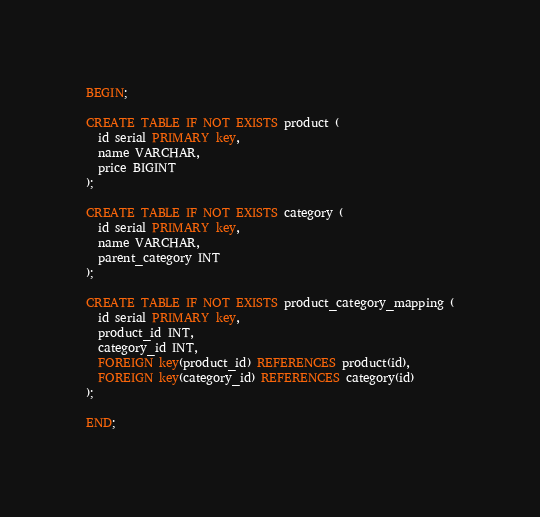<code> <loc_0><loc_0><loc_500><loc_500><_SQL_>BEGIN;

CREATE TABLE IF NOT EXISTS product (
  id serial PRIMARY key, 
  name VARCHAR, 
  price BIGINT
);

CREATE TABLE IF NOT EXISTS category (
  id serial PRIMARY key, 
  name VARCHAR,
  parent_category INT
);

CREATE TABLE IF NOT EXISTS product_category_mapping (
  id serial PRIMARY key, 
  product_id INT, 
  category_id INT, 
  FOREIGN key(product_id) REFERENCES product(id), 
  FOREIGN key(category_id) REFERENCES category(id)
);

END;
</code> 